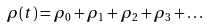Convert formula to latex. <formula><loc_0><loc_0><loc_500><loc_500>\rho ( t ) = \rho _ { 0 } + \rho _ { 1 } + \rho _ { 2 } + \rho _ { 3 } + \dots</formula> 